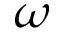<formula> <loc_0><loc_0><loc_500><loc_500>\omega</formula> 